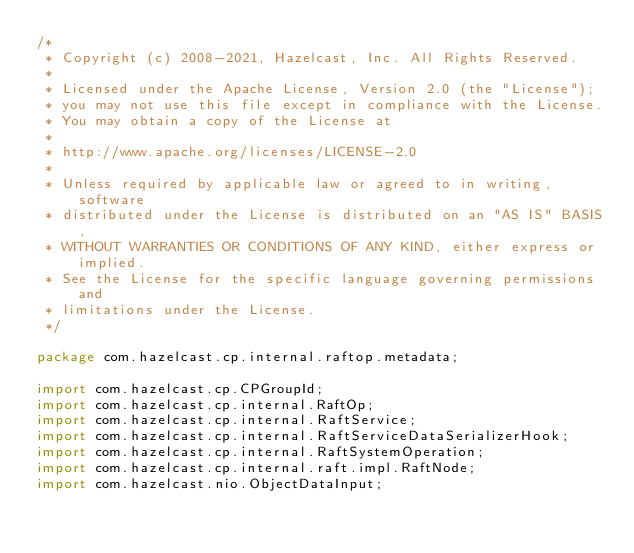<code> <loc_0><loc_0><loc_500><loc_500><_Java_>/*
 * Copyright (c) 2008-2021, Hazelcast, Inc. All Rights Reserved.
 *
 * Licensed under the Apache License, Version 2.0 (the "License");
 * you may not use this file except in compliance with the License.
 * You may obtain a copy of the License at
 *
 * http://www.apache.org/licenses/LICENSE-2.0
 *
 * Unless required by applicable law or agreed to in writing, software
 * distributed under the License is distributed on an "AS IS" BASIS,
 * WITHOUT WARRANTIES OR CONDITIONS OF ANY KIND, either express or implied.
 * See the License for the specific language governing permissions and
 * limitations under the License.
 */

package com.hazelcast.cp.internal.raftop.metadata;

import com.hazelcast.cp.CPGroupId;
import com.hazelcast.cp.internal.RaftOp;
import com.hazelcast.cp.internal.RaftService;
import com.hazelcast.cp.internal.RaftServiceDataSerializerHook;
import com.hazelcast.cp.internal.RaftSystemOperation;
import com.hazelcast.cp.internal.raft.impl.RaftNode;
import com.hazelcast.nio.ObjectDataInput;</code> 